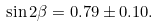Convert formula to latex. <formula><loc_0><loc_0><loc_500><loc_500>\sin 2 \beta = 0 . 7 9 \pm 0 . 1 0 .</formula> 